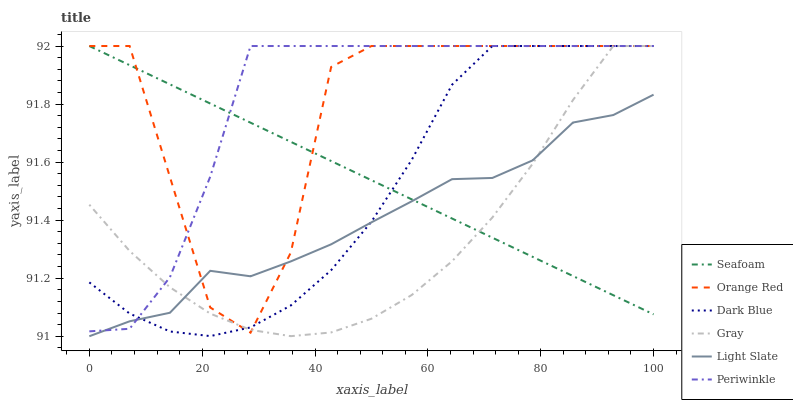Does Gray have the minimum area under the curve?
Answer yes or no. Yes. Does Periwinkle have the maximum area under the curve?
Answer yes or no. Yes. Does Light Slate have the minimum area under the curve?
Answer yes or no. No. Does Light Slate have the maximum area under the curve?
Answer yes or no. No. Is Seafoam the smoothest?
Answer yes or no. Yes. Is Orange Red the roughest?
Answer yes or no. Yes. Is Light Slate the smoothest?
Answer yes or no. No. Is Light Slate the roughest?
Answer yes or no. No. Does Light Slate have the lowest value?
Answer yes or no. Yes. Does Seafoam have the lowest value?
Answer yes or no. No. Does Orange Red have the highest value?
Answer yes or no. Yes. Does Light Slate have the highest value?
Answer yes or no. No. Does Light Slate intersect Periwinkle?
Answer yes or no. Yes. Is Light Slate less than Periwinkle?
Answer yes or no. No. Is Light Slate greater than Periwinkle?
Answer yes or no. No. 